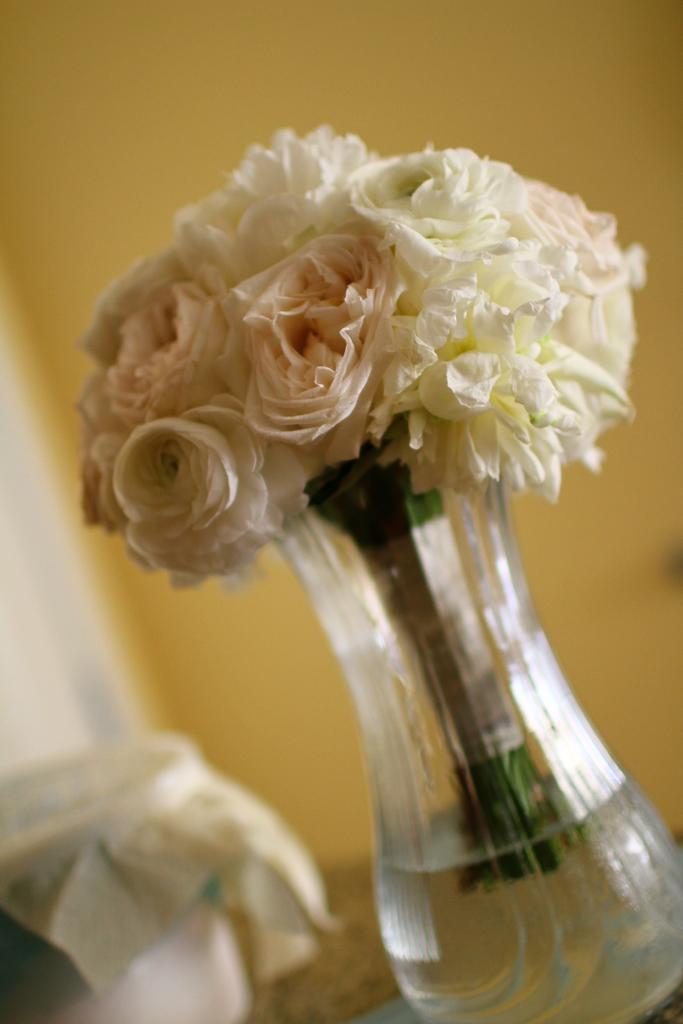In one or two sentences, can you explain what this image depicts? In this picture we can see a flower vase in the front, there is some water and flowers present in the vase, in the background there is a wall, we can see a blurry background, at the left bottom there is a box. 